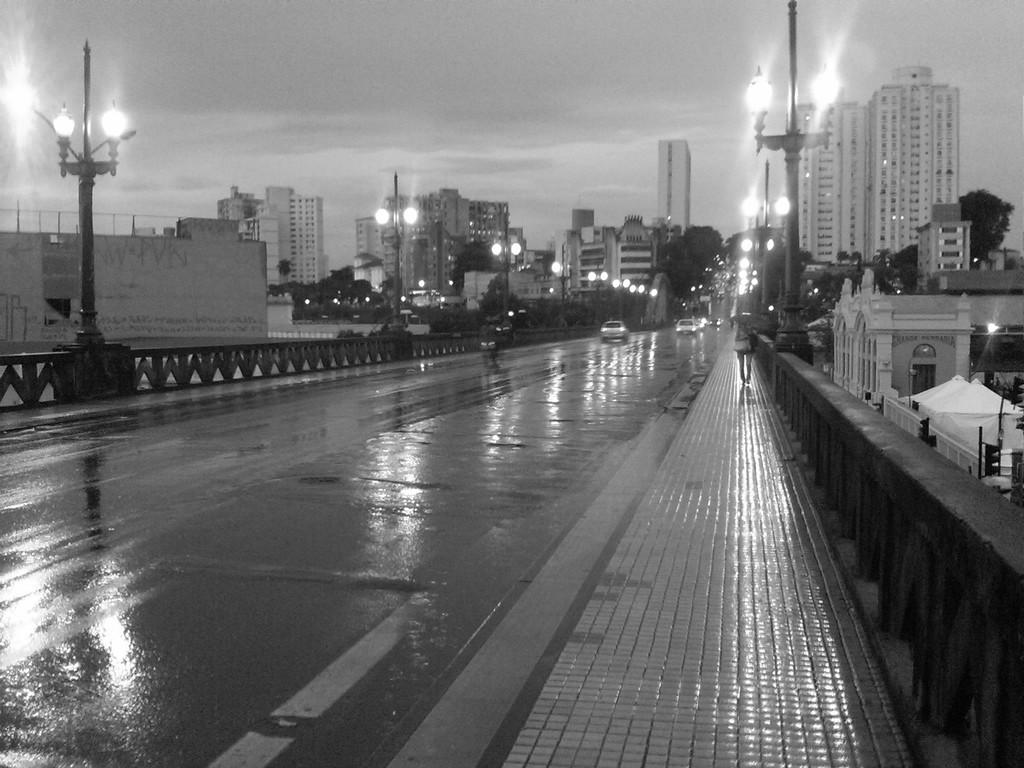What type of lighting can be seen in the image? There are street lamps in the image. What is separating the area in the image? There is a fence in the image. What is the person in the image doing? A person is walking in the image. What type of transportation is present in the image? There are vehicles in the image. What type of vegetation is present in the image? There are trees in the image. What type of structures are present in the image? There are buildings in the image. What is visible at the top of the image? The sky is visible at the top of the image. What is the monkey doing with its thumb in the image? There is no monkey present in the image, so it is not possible to answer that question. 